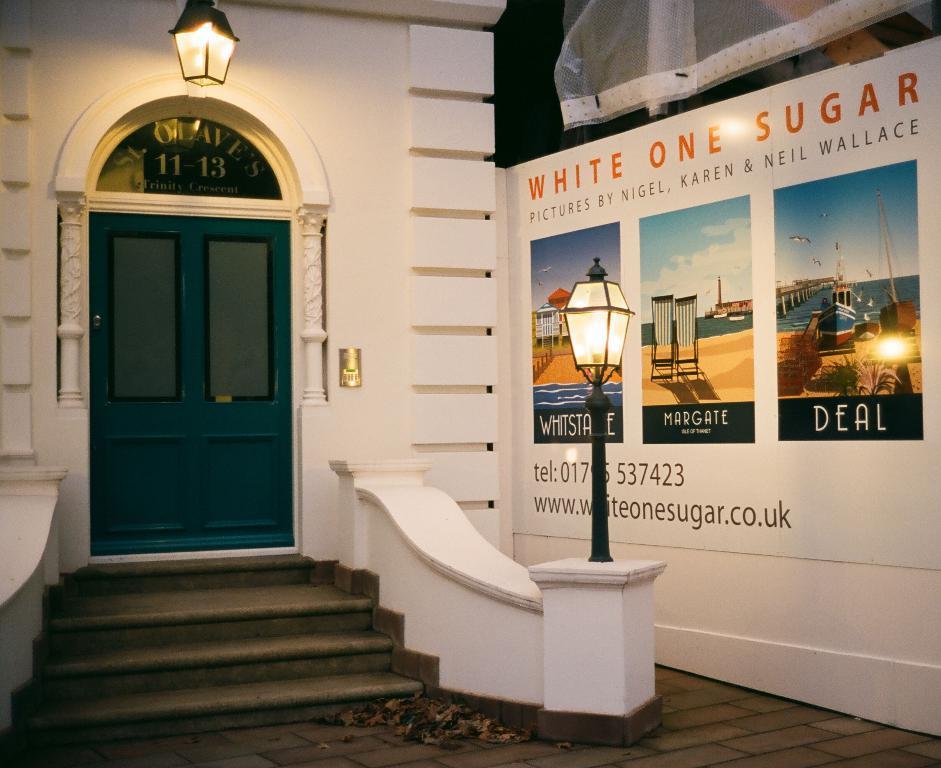In one or two sentences, can you explain what this image depicts? In this picture we can see the stairway and the lamps and we can see the door of the house and we can see the text on the house. On the right we can see a curtain and a banner on which we can see the text, numbers and some pictures containing sky, water body, boat, beach chairs and some other objects. 